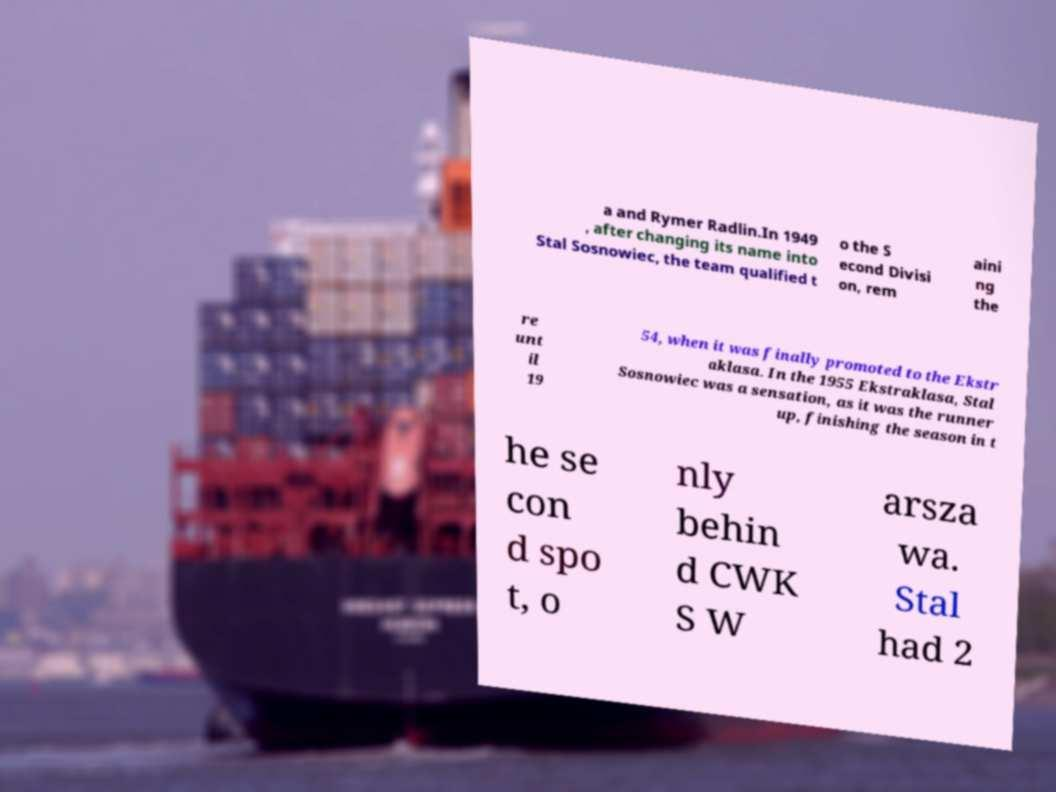I need the written content from this picture converted into text. Can you do that? a and Rymer Radlin.In 1949 , after changing its name into Stal Sosnowiec, the team qualified t o the S econd Divisi on, rem aini ng the re unt il 19 54, when it was finally promoted to the Ekstr aklasa. In the 1955 Ekstraklasa, Stal Sosnowiec was a sensation, as it was the runner up, finishing the season in t he se con d spo t, o nly behin d CWK S W arsza wa. Stal had 2 